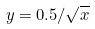<formula> <loc_0><loc_0><loc_500><loc_500>y = 0 . 5 / \sqrt { x }</formula> 